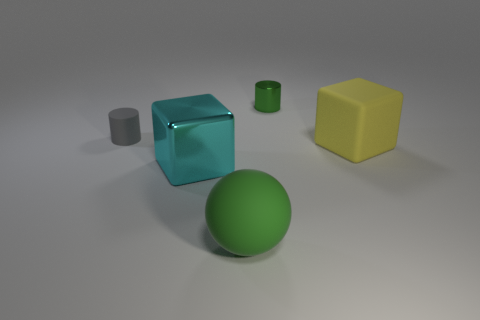Add 3 big cubes. How many objects exist? 8 Subtract all cubes. How many objects are left? 3 Add 5 green cylinders. How many green cylinders are left? 6 Add 4 gray metallic cylinders. How many gray metallic cylinders exist? 4 Subtract 0 brown cylinders. How many objects are left? 5 Subtract all big purple rubber spheres. Subtract all large things. How many objects are left? 2 